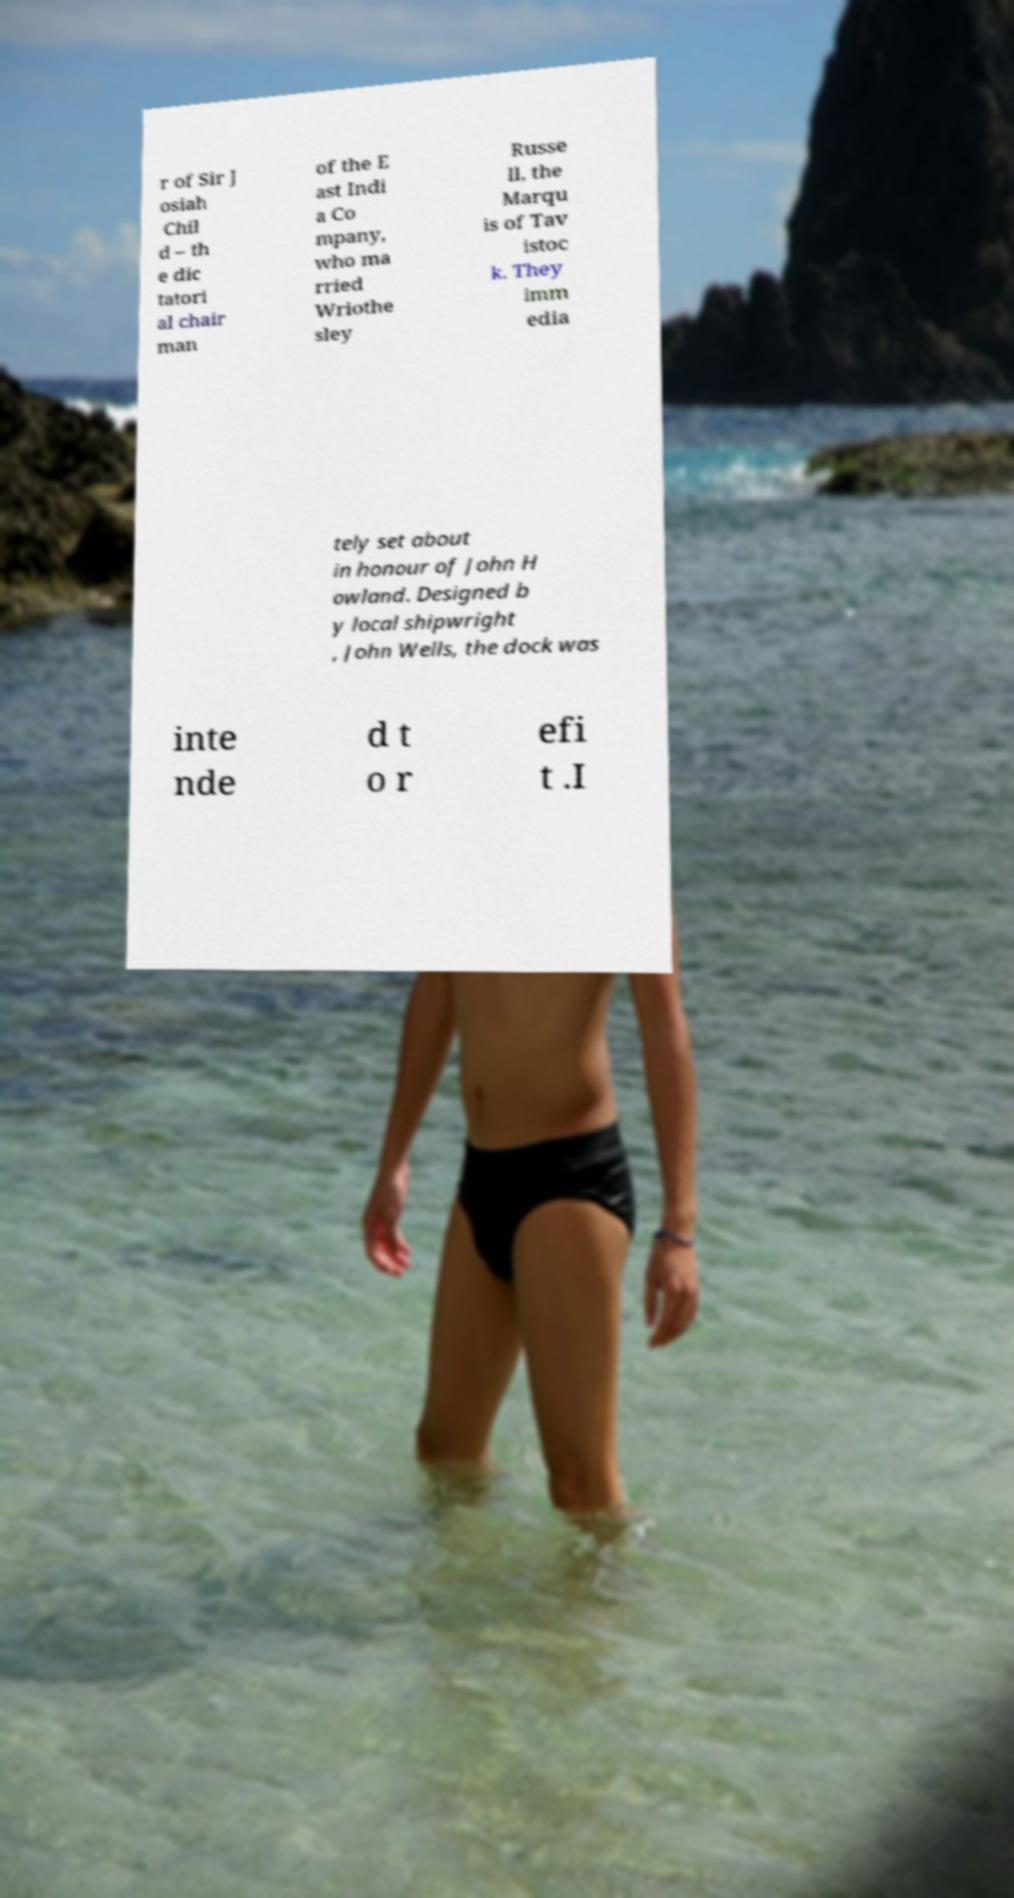There's text embedded in this image that I need extracted. Can you transcribe it verbatim? r of Sir J osiah Chil d – th e dic tatori al chair man of the E ast Indi a Co mpany, who ma rried Wriothe sley Russe ll, the Marqu is of Tav istoc k. They imm edia tely set about in honour of John H owland. Designed b y local shipwright , John Wells, the dock was inte nde d t o r efi t .I 